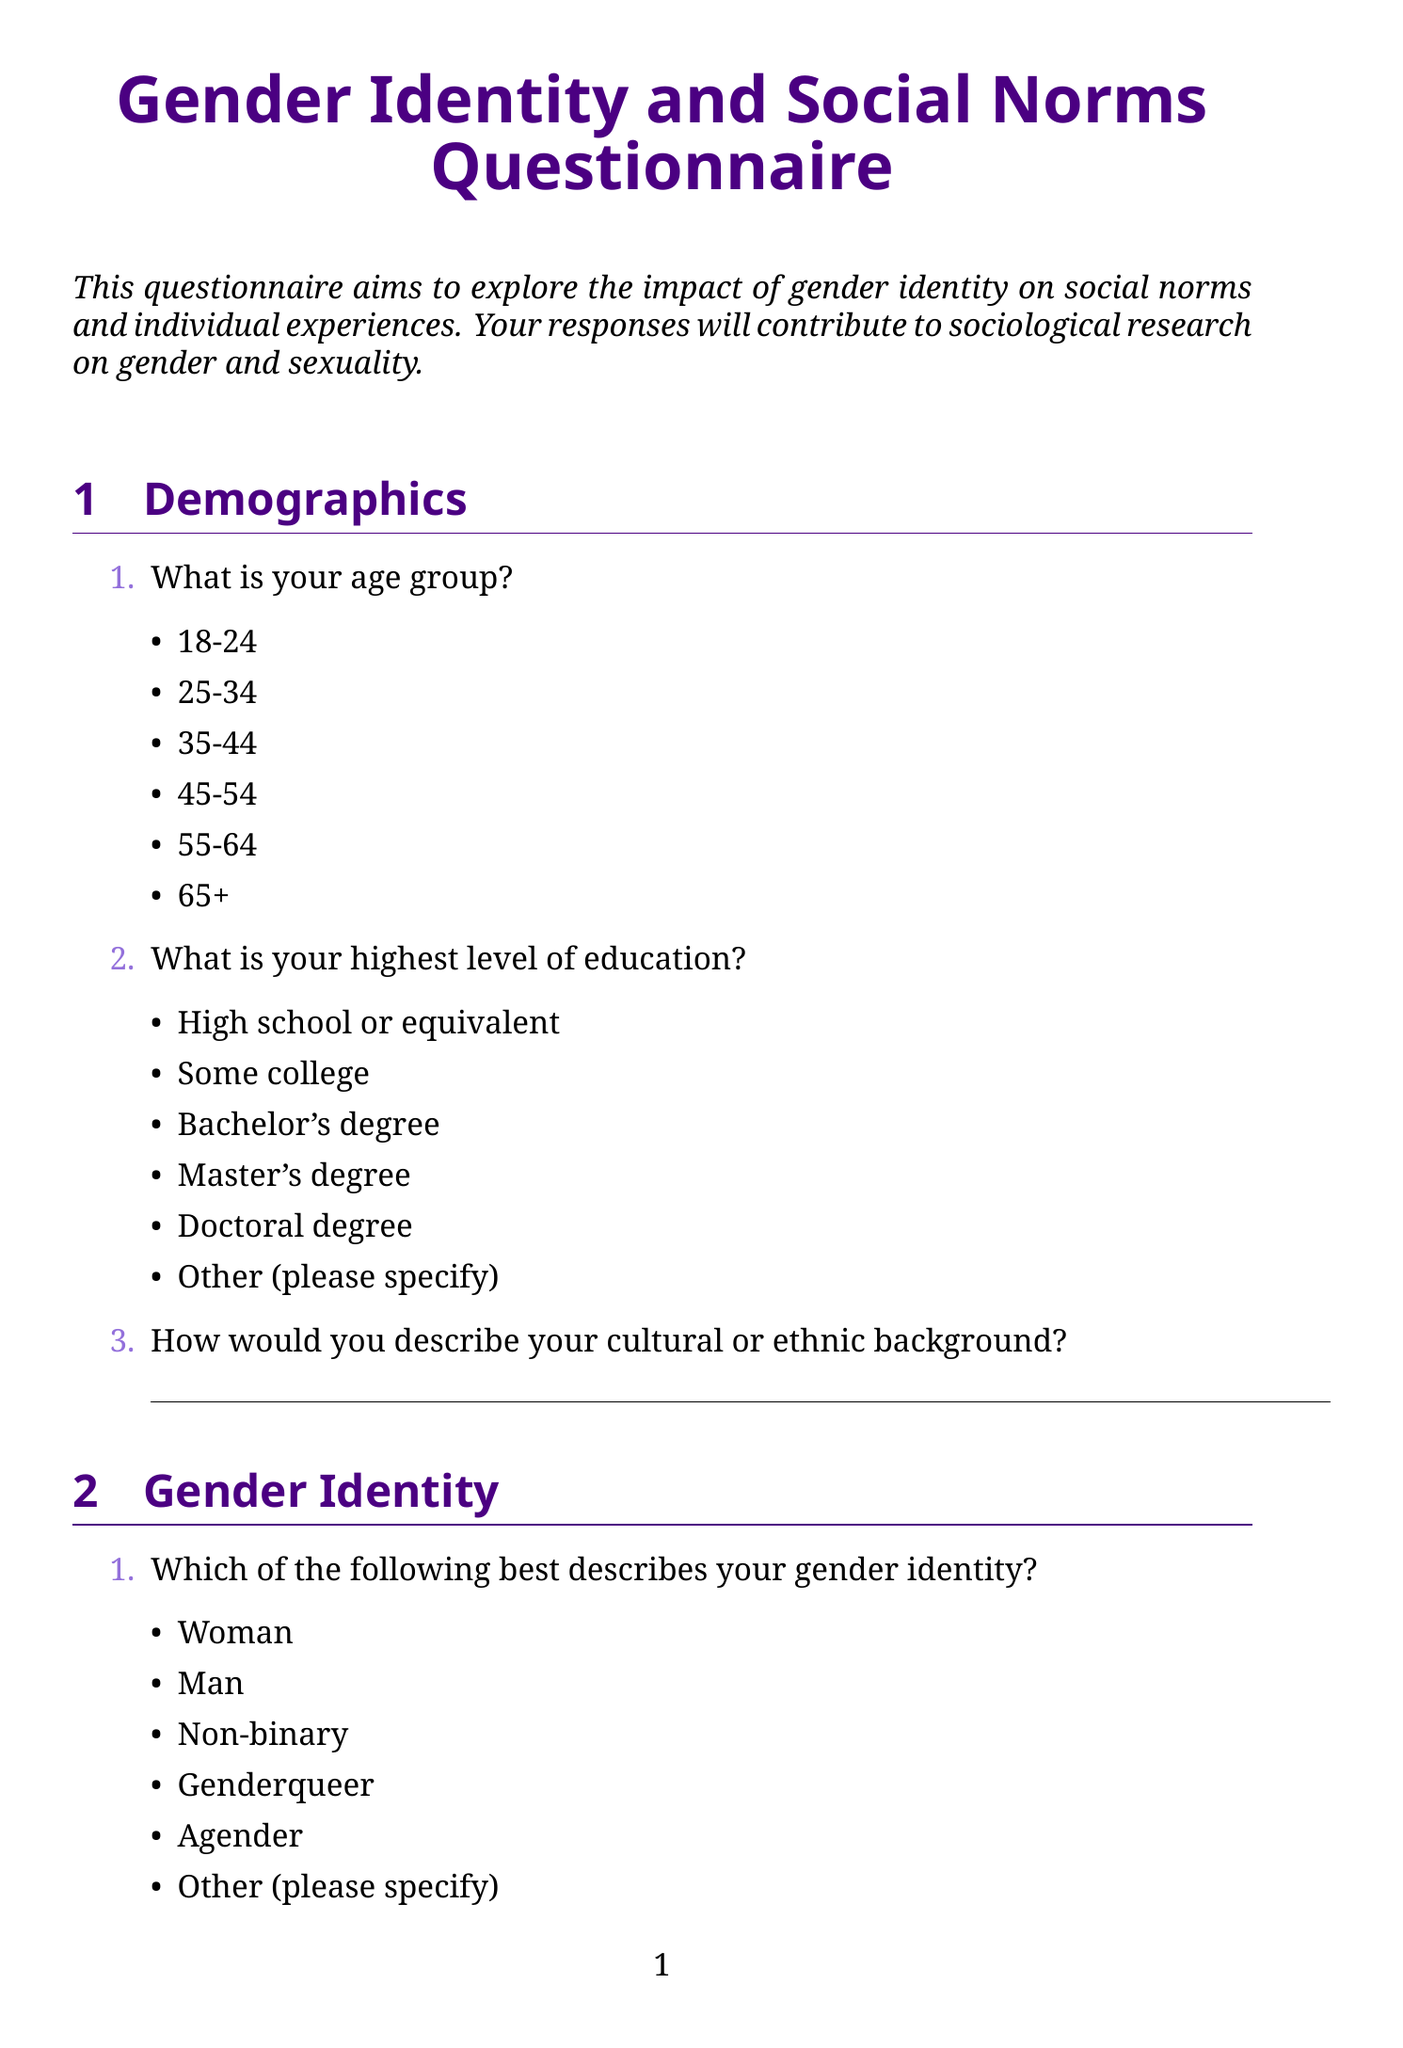What is the title of the questionnaire? The title of the questionnaire is presented at the beginning of the document, emphasizing its purpose in the exploration of gender identity.
Answer: Gender Identity and Social Norms Questionnaire What age group is included in the demographics section? The demographics section lists various age groups as options for respondents to select from.
Answer: 18-24, 25-34, 35-44, 45-54, 55-64, 65+ What type of question is related to the evolution of gender identity understanding? This question is framed to gather personal insights from respondents about their experiences with gender identity.
Answer: open-ended Which social institution is mentioned as having the strongest influence on gender norms? The document provides options for respondents to identify the social institution that influences gender norms.
Answer: Family, Education system, Media, Religious institutions, Workplace, Government How comfortable do participants feel expressing their gender identity in public? The document lists different levels of comfort as response options, signaling varied experiences regarding public expression of gender identity.
Answer: Very uncomfortable, Somewhat uncomfortable, Neutral, Somewhat comfortable, Very comfortable What is the frequency of activism related to gender identity participation? The document asks respondents about their involvement in activism, indicating a range of possible engagement levels.
Answer: Yes, frequently, Yes, occasionally, No, but I would like to, No, and I'm not interested What changes are hoped for in society's understanding of gender identity? This is an open-ended question allowing respondents to express their visions for future societal changes around gender identity.
Answer: open-ended Which intersection aspect is most significant to gender identity, according to the questionnaire? Respondents are prompted to identify which aspect interacts most significantly with their gender identity, showing the interconnectedness of identities.
Answer: Race/ethnicity, Socioeconomic status, Sexual orientation, Religion, Disability status, Nationality How often do respondents feel pressure to conform to traditional gender roles? The questionnaire includes a multiple-choice option addressing the frequency of pressure respondents experience in conforming to established gender roles.
Answer: Never, Rarely, Sometimes, Often, Always 